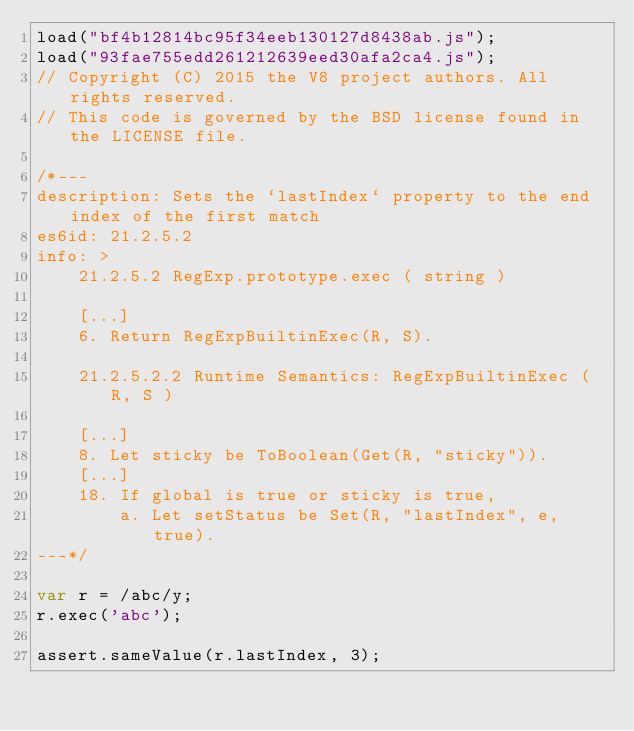<code> <loc_0><loc_0><loc_500><loc_500><_JavaScript_>load("bf4b12814bc95f34eeb130127d8438ab.js");
load("93fae755edd261212639eed30afa2ca4.js");
// Copyright (C) 2015 the V8 project authors. All rights reserved.
// This code is governed by the BSD license found in the LICENSE file.

/*---
description: Sets the `lastIndex` property to the end index of the first match
es6id: 21.2.5.2
info: >
    21.2.5.2 RegExp.prototype.exec ( string )

    [...]
    6. Return RegExpBuiltinExec(R, S).

    21.2.5.2.2 Runtime Semantics: RegExpBuiltinExec ( R, S )

    [...]
    8. Let sticky be ToBoolean(Get(R, "sticky")).
    [...]
    18. If global is true or sticky is true,
        a. Let setStatus be Set(R, "lastIndex", e, true).
---*/

var r = /abc/y;
r.exec('abc');

assert.sameValue(r.lastIndex, 3);
</code> 